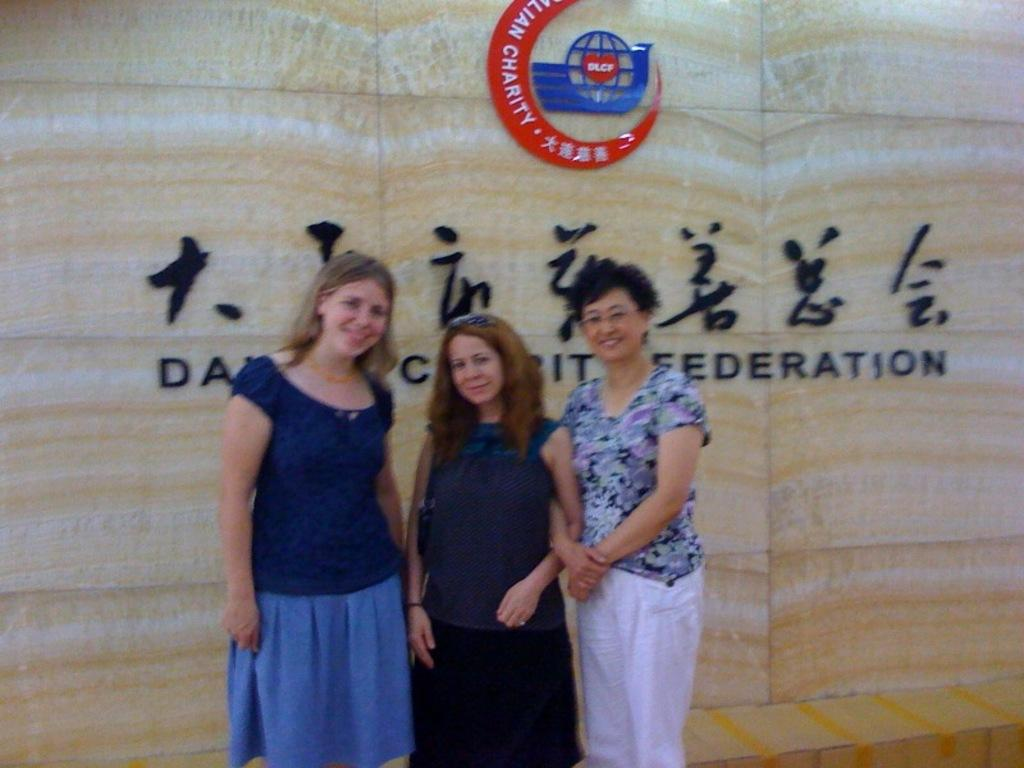How many people are present in the image? There are three persons standing in the image. What is located behind the persons? There is a wall behind the persons. What can be seen on the wall? There is text written on the wall and a logo represented on the wall. What is the tendency of the aunt in the image? There is no aunt present in the image, so it is not possible to determine any tendencies. 